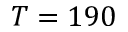<formula> <loc_0><loc_0><loc_500><loc_500>T = 1 9 0</formula> 